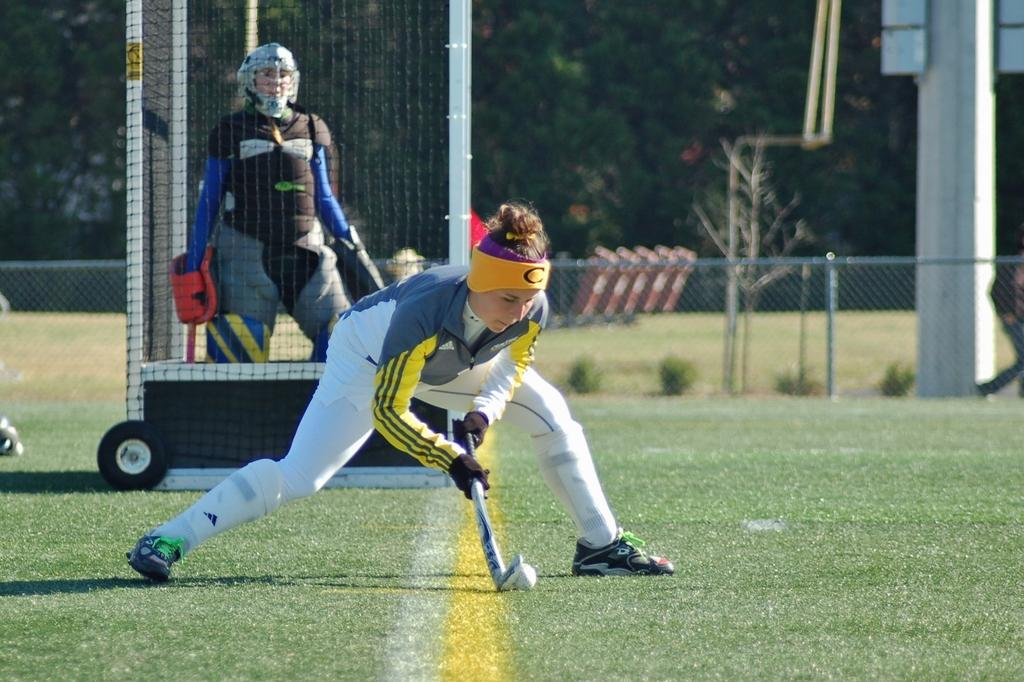Who is the main subject in the image? There is a woman in the image. What activity is the woman engaged in? The woman is playing baseball. What equipment is used in the game of baseball that is visible in the image? There is a ball and a bat in the image. What structures can be seen in the image? There is a fence, a mesh, a pillar, and a board in the image. What type of vegetation is present in the image? There are plants and trees in the image. Can you describe the background of the image? The background of the image includes trees. What type of spark can be seen in the image? There is no spark present in the image. 